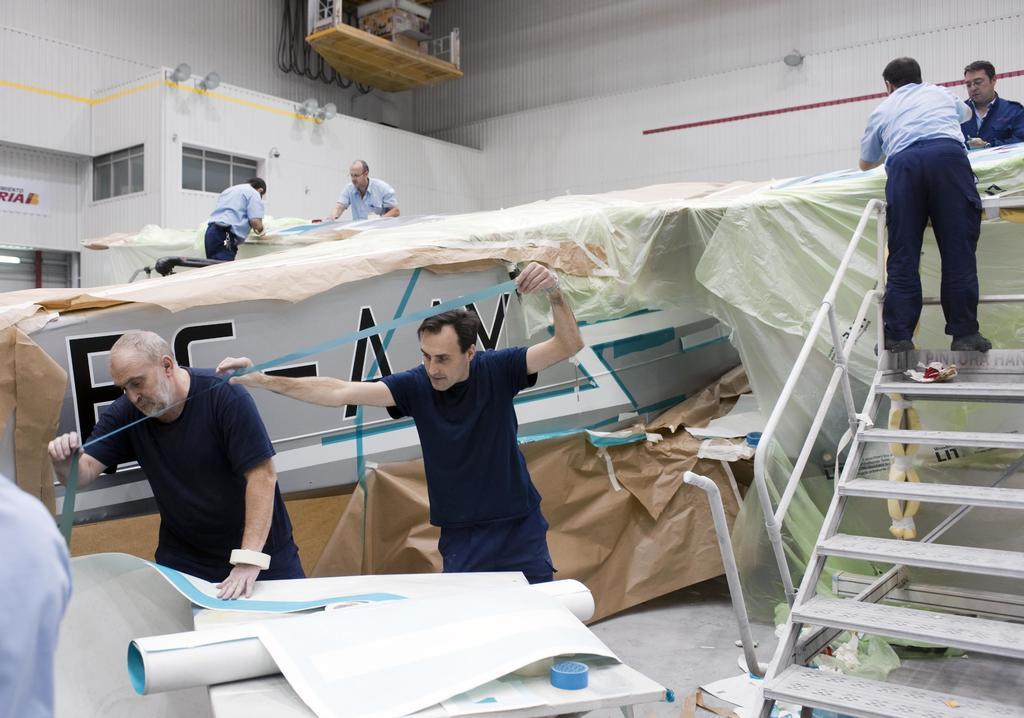In one or two sentences, can you explain what this image depicts? In the center of the image we can see a few people are standing and they are holding some objects. And we can see a table, tape, railing, staircase, one solid structure with some text, papers, charts, covers and some objects. On the left side of the image, we can see a cloth. In the background there is a wall and a few other objects. 